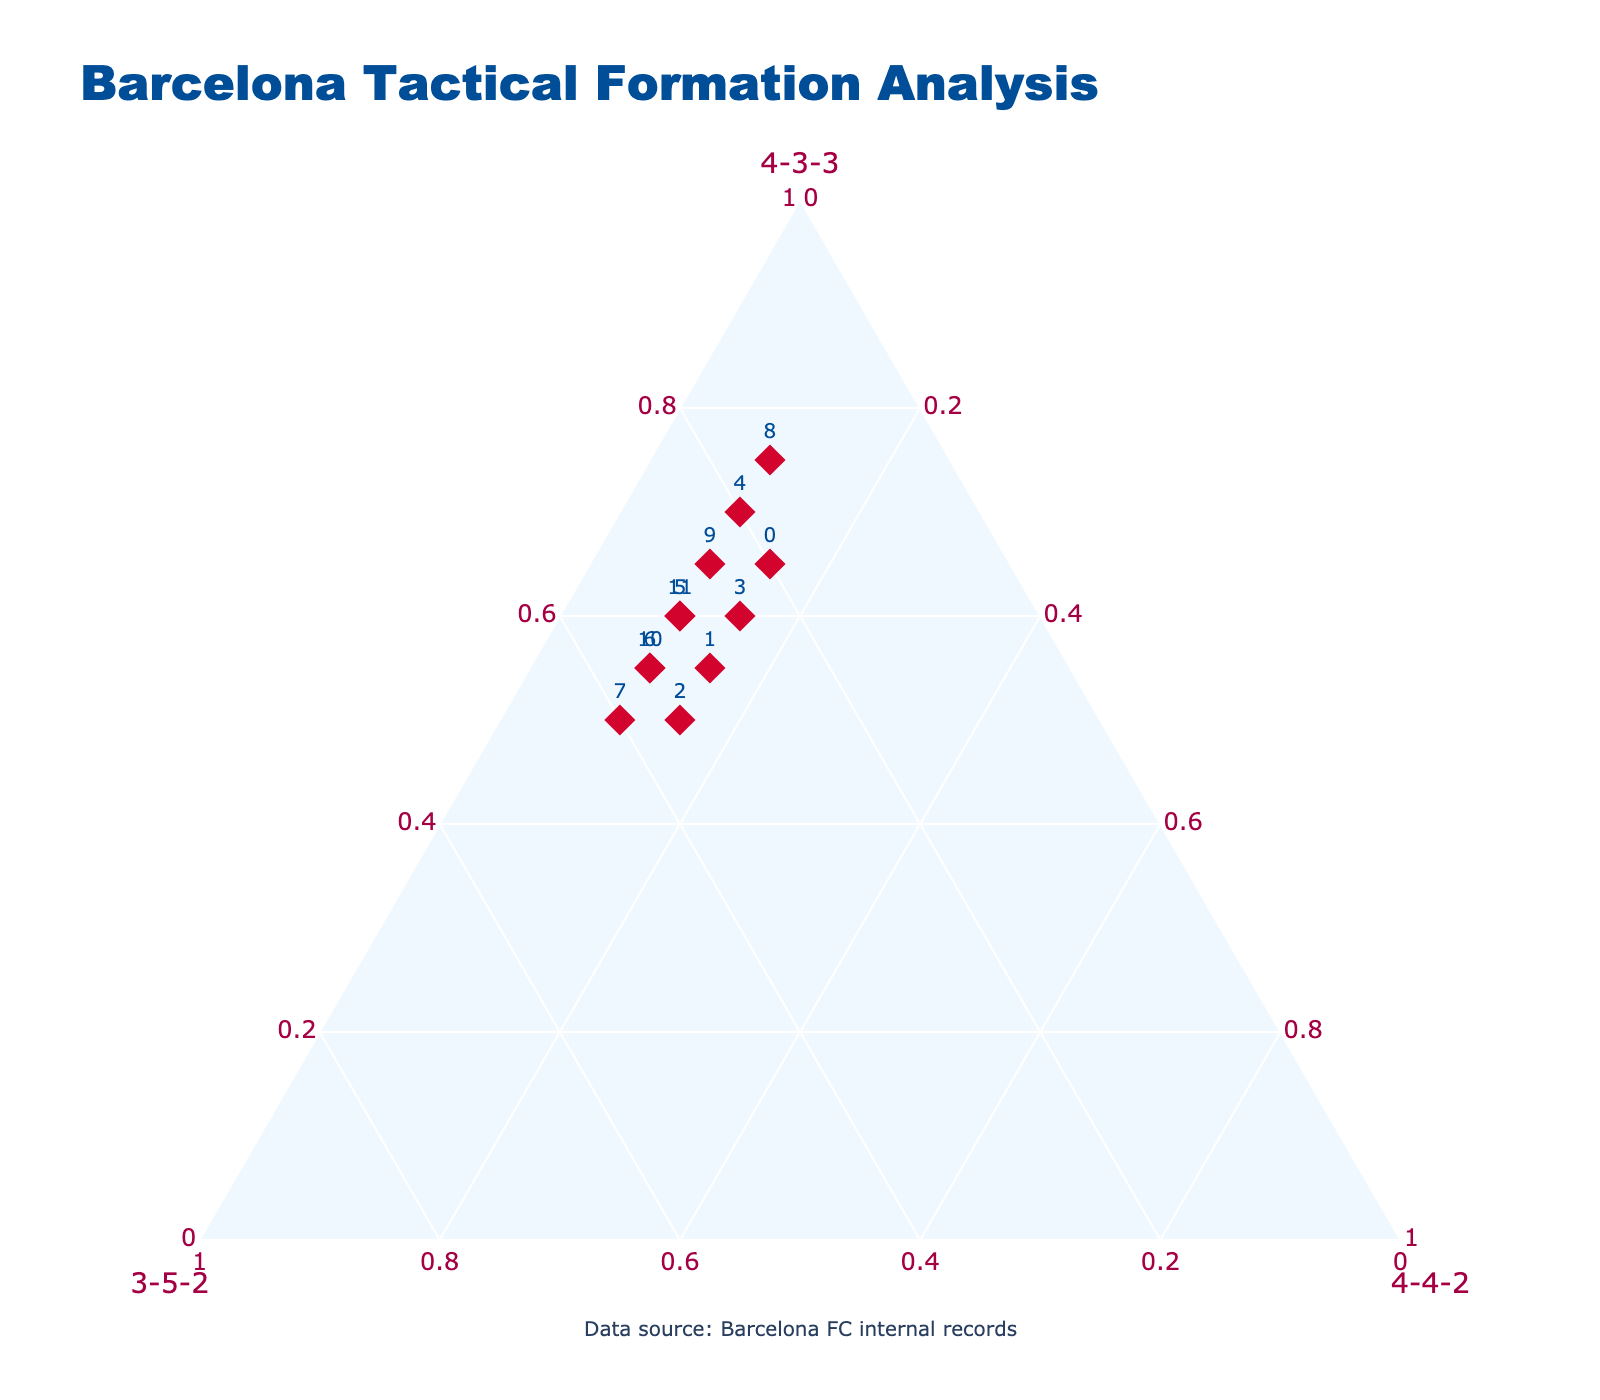what is the most frequently used tactical formation during the 2018-19 season? The plot shows that in the 2018-19 season, the 4-3-3 formation point is closer to the top vertex, indicating it is used for 70% of the time. This is the highest proportion compared to the other formations for that season.
Answer: 4-3-3 How did the use of the 3-5-2 formation change between the 2014-15 and 2015-16 seasons? In the plot, for the 2014-15 season, the 3-5-2 formation point is at roughly 20%. For the 2015-16 season, it increases to 30%. Calculating the difference: 30% - 20% = 10%.
Answer: Increased by 10% Which era shows the greatest diversity in formations used? By inspecting the eras, Guardiola Era is predominantly using 4-3-3 at 75%, while the other formations are significantly lower. Comparatively, Valverde, Koeman, and Xavi Eras show a more balanced variety, with Xavi Era and Koeman Era each showing similarly high usage of both 4-3-3 and 3-5-2 formations. However, Xavi Era has slightly richer diversity as the 3-5-2 proportion reaches 30%.
Answer: Xavi Era During which season did the 4-4-2 formation have a stable (unchanged) portion? The 4-4-2 formation portion is consistently shown by a point positioned at 15% from 2014-15 to 2017-18 season. It indicates the formation was stably used across these seasons without variation.
Answer: 2014-15 to 2017-18 seasons Which seasons show similar usage patterns for all three formations? Checking the points on the plot, the 2015-16 and 2016-17 Seasons have nearly identical patterns with small variations. Both seasons show prominently higher 4-3-3 usage and similar proportions for the other two formations.
Answer: 2015-16 and 2016-17 seasons How much did the proportion of the 4-4-2 formation decrease from the 2014-15 season in any of the subsequent seasons? From 2014-15, where 4-4-2 formation is at 15%, it drops to 10% in the 2018-19 season. The difference is 15% - 10% = 5%.
Answer: 5% During which era did the 3-5-2 formation have the highest usage? Observing the points representing each era, Koeman Era shows the highest usage of the 3-5-2 formation at 35%, which is more than during Guardiola, Valverde, or Xavi Eras.
Answer: Koeman Era What is the approximate median percentage of time spent in the 4-3-3 formation across all points on the ternary plot? Examining the list of all 4-3-3 values (0.65, 0.55, 0.50, 0.60, 0.70, 0.60, 0.55, 0.50, 0.75, 0.65, 0.55, 0.60), the median falls between the values for the 6th and 7th sorted entries. Thus, (0.60 + 0.60) / 2 = 0.60, or 60%.
Answer: 60% 